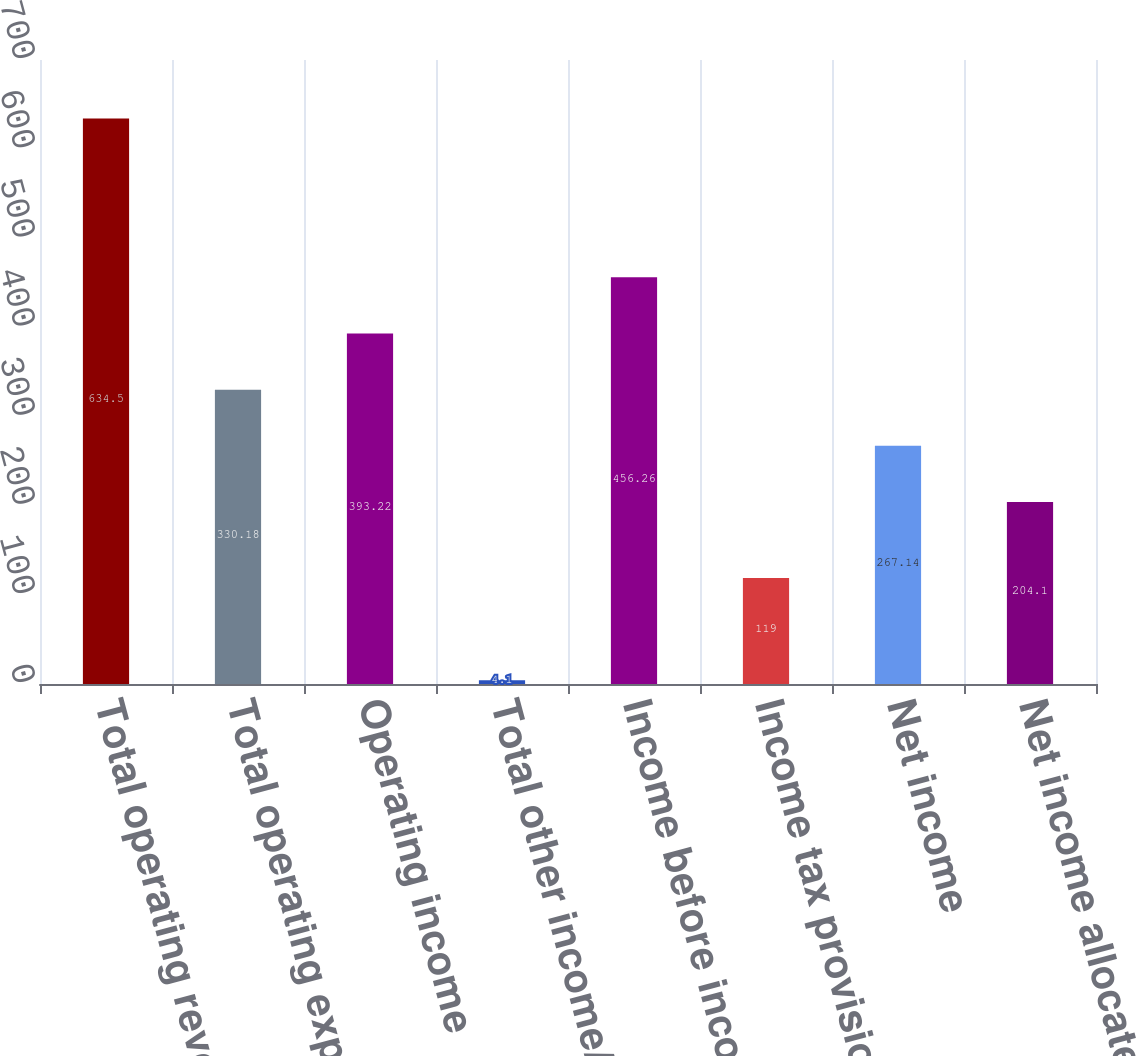<chart> <loc_0><loc_0><loc_500><loc_500><bar_chart><fcel>Total operating revenues<fcel>Total operating expenses<fcel>Operating income<fcel>Total other income/(expense)<fcel>Income before income taxes<fcel>Income tax provision<fcel>Net income<fcel>Net income allocated to common<nl><fcel>634.5<fcel>330.18<fcel>393.22<fcel>4.1<fcel>456.26<fcel>119<fcel>267.14<fcel>204.1<nl></chart> 